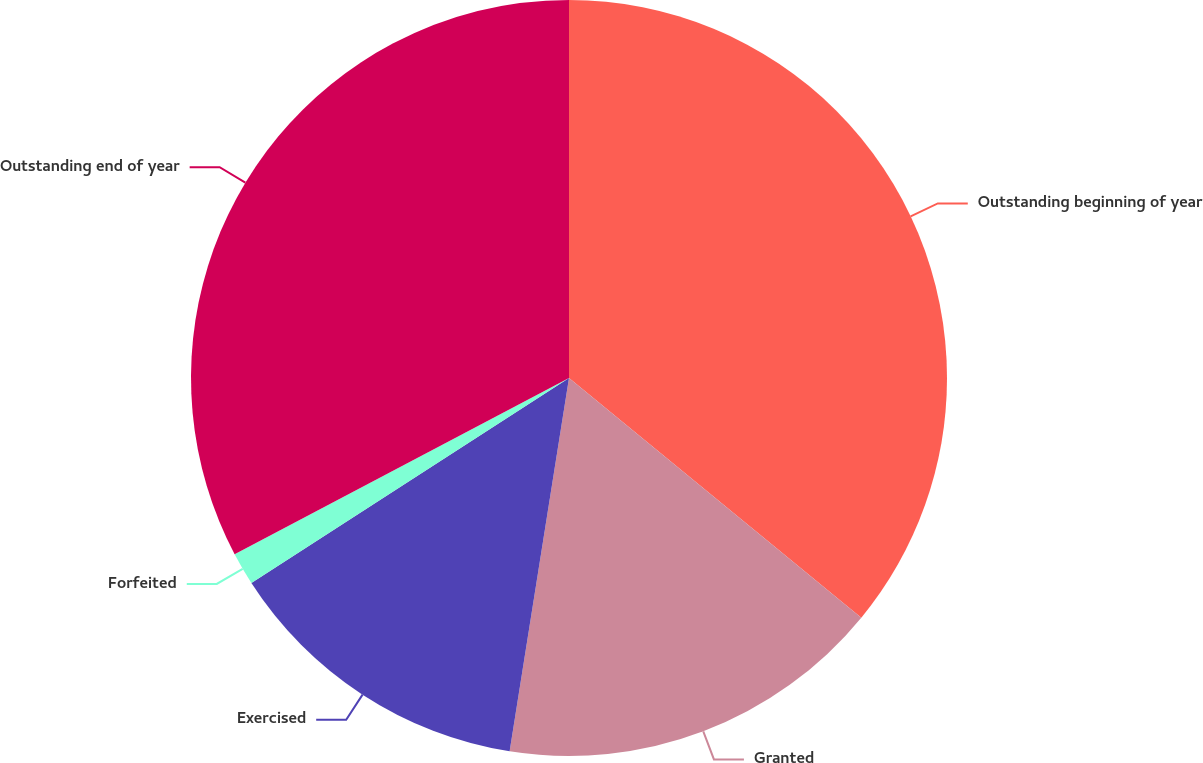<chart> <loc_0><loc_0><loc_500><loc_500><pie_chart><fcel>Outstanding beginning of year<fcel>Granted<fcel>Exercised<fcel>Forfeited<fcel>Outstanding end of year<nl><fcel>35.93%<fcel>16.58%<fcel>13.37%<fcel>1.4%<fcel>32.72%<nl></chart> 